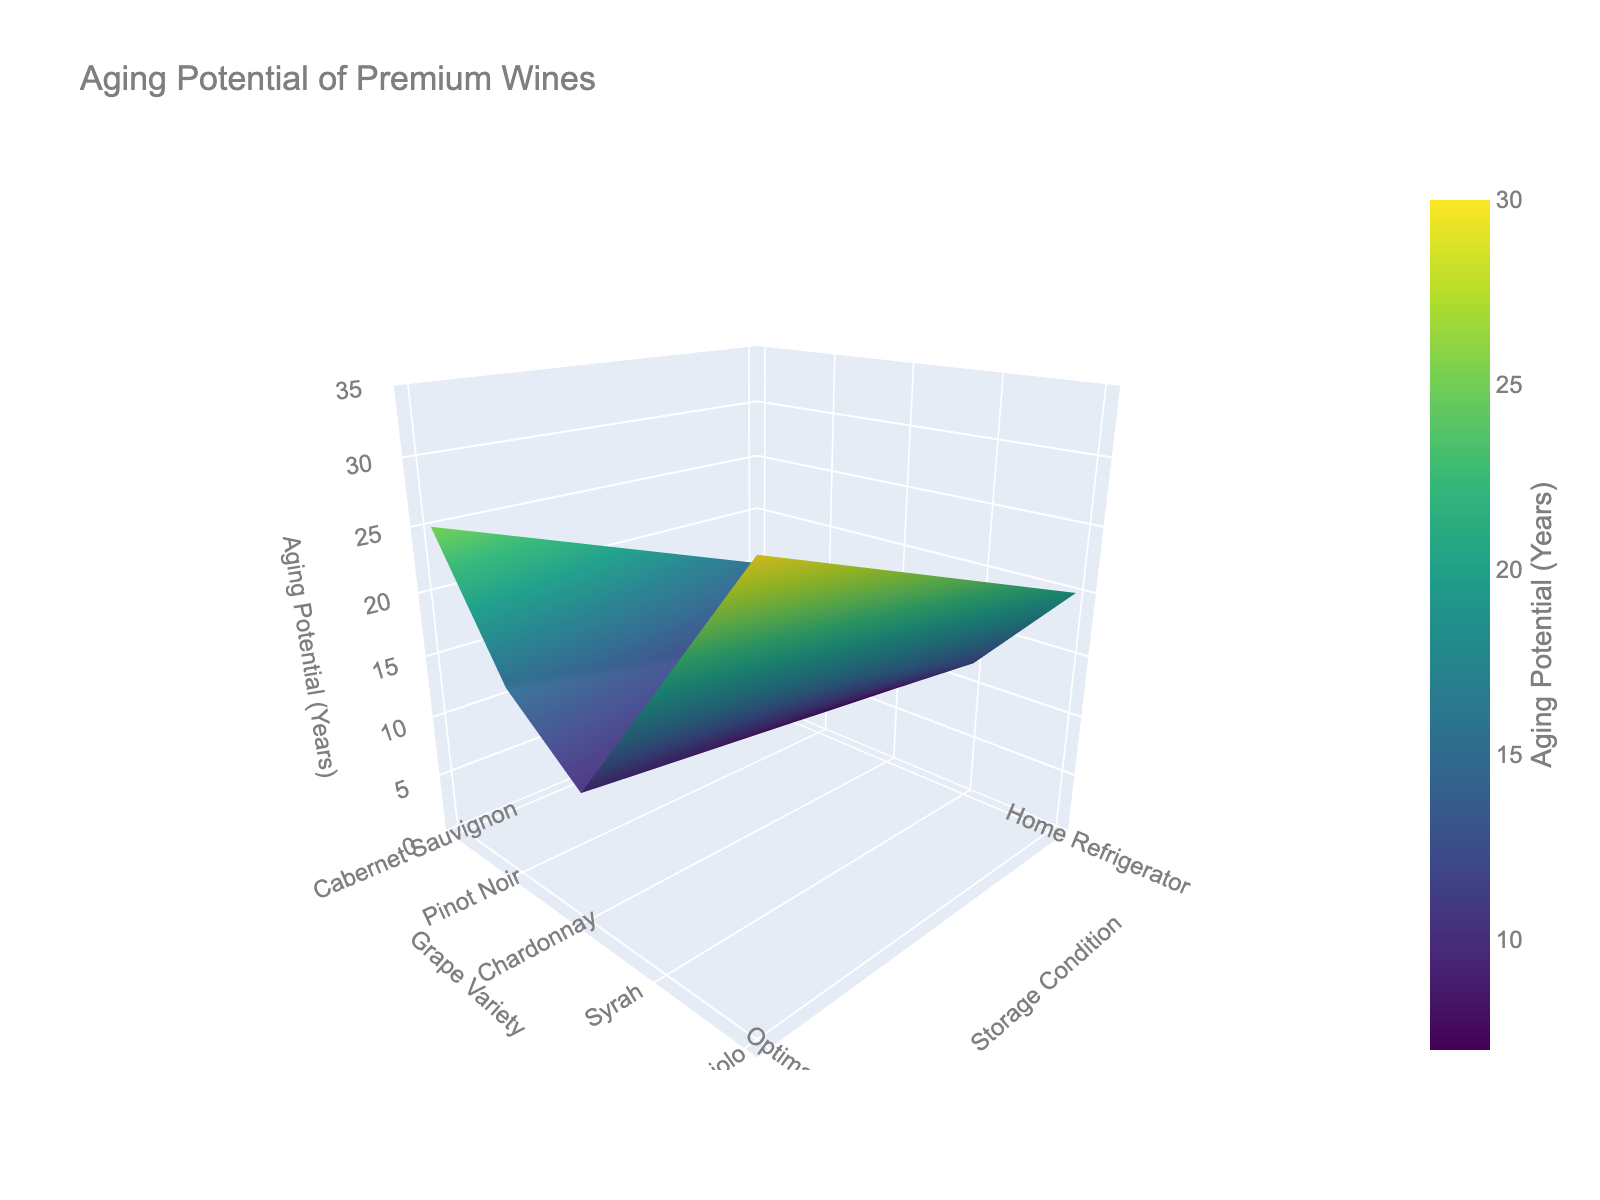What is the title of the plot? The title is typically displayed at the top of the plot. In this case, it is stated in the figure settings provided in the code.
Answer: Aging Potential of Premium Wines Which grape variety has the highest aging potential in optimal cellar conditions? Look at the z-axis value (Aging Potential in Years) for each grape variety when the storage condition is Optimal Cellar. Nebbiolo has the highest value, which is 30 years.
Answer: Nebbiolo How does the aging potential of Pinot Noir compare between optimal cellar conditions and home refrigerator conditions? Observe the z-axis values for Pinot Noir in optimal cellar conditions and home refrigerator conditions. In optimal cellar conditions, the aging potential is 15 years, while in home refrigerator conditions, it is 10 years.
Answer: It is 5 years higher in optimal cellar conditions Which storage condition generally results in higher aging potential across all grape varieties? Compare the z-axis values for both storage conditions across all grape varieties. The values are generally higher for Optimal Cellar conditions compared to Home Refrigerator conditions.
Answer: Optimal Cellar For which grape variety is the difference in aging potential the largest between the two storage conditions? Calculate the difference in z-axis values between Optimal Cellar and Home Refrigerator conditions for each grape variety. The largest difference is for Nebbiolo, with Optimal Cellar at 30 years and Home Refrigerator at 20 years, making a difference of 10 years.
Answer: Nebbiolo Is there any grape variety where home refrigerator storage has a higher aging potential than optimal cellar conditions? Compare the z-axis values for Home Refrigerator and Optimal Cellar conditions for each grape variety. None of the grape varieties have higher aging potential in Home Refrigerator conditions.
Answer: No What are the aging potentials for Syrah in both storage conditions when the initial quality rating is 95? Look at the z-axis values for Syrah. In Optimal Cellar conditions, the aging potential is 20 years. In Home Refrigerator conditions, it is 12 years.
Answer: 20 years and 12 years Which grape variety has the lowest aging potential in home refrigerator conditions with an initial quality rating of 95? Identify the lowest z-axis value for Home Refrigerator conditions. Chardonnay has the lowest value of 7 years.
Answer: Chardonnay What is the average aging potential for Chardonnay across both storage conditions? Calculate the average of the z-axis values for Chardonnay. In Optimal Cellar, it is 10 years, and in Home Refrigerator, it is 7 years. The average is (10 + 7) / 2.
Answer: 8.5 years 